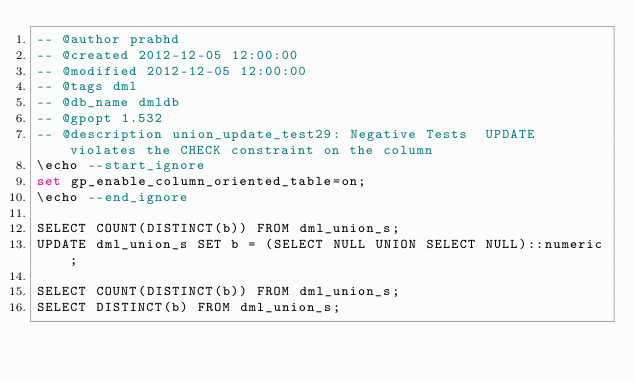<code> <loc_0><loc_0><loc_500><loc_500><_SQL_>-- @author prabhd 
-- @created 2012-12-05 12:00:00 
-- @modified 2012-12-05 12:00:00 
-- @tags dml 
-- @db_name dmldb
-- @gpopt 1.532
-- @description union_update_test29: Negative Tests  UPDATE violates the CHECK constraint on the column
\echo --start_ignore
set gp_enable_column_oriented_table=on;
\echo --end_ignore

SELECT COUNT(DISTINCT(b)) FROM dml_union_s;
UPDATE dml_union_s SET b = (SELECT NULL UNION SELECT NULL)::numeric;

SELECT COUNT(DISTINCT(b)) FROM dml_union_s;
SELECT DISTINCT(b) FROM dml_union_s;

</code> 